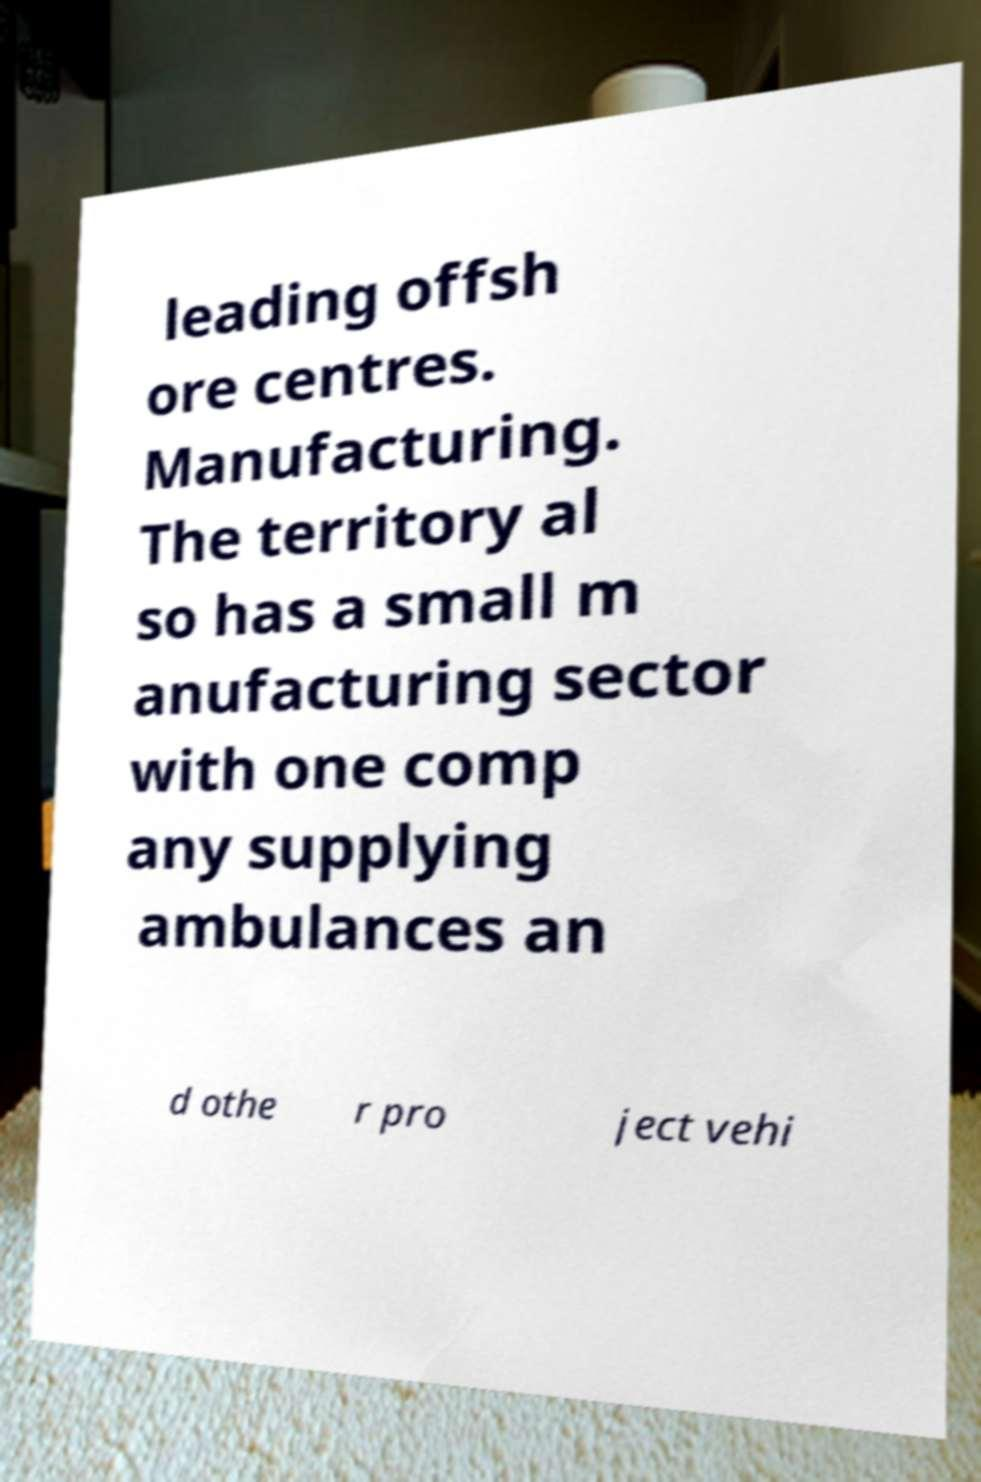Can you read and provide the text displayed in the image?This photo seems to have some interesting text. Can you extract and type it out for me? leading offsh ore centres. Manufacturing. The territory al so has a small m anufacturing sector with one comp any supplying ambulances an d othe r pro ject vehi 